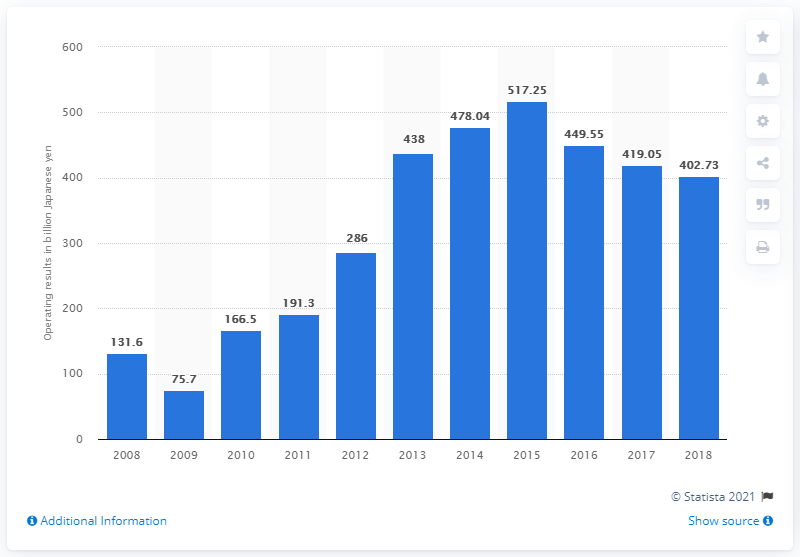Draw attention to some important aspects in this diagram. In the year 2008, Bridgestone's fiscal year was. In the fiscal year of 2018, Bridgestone's operating income in yen was 402.73. 